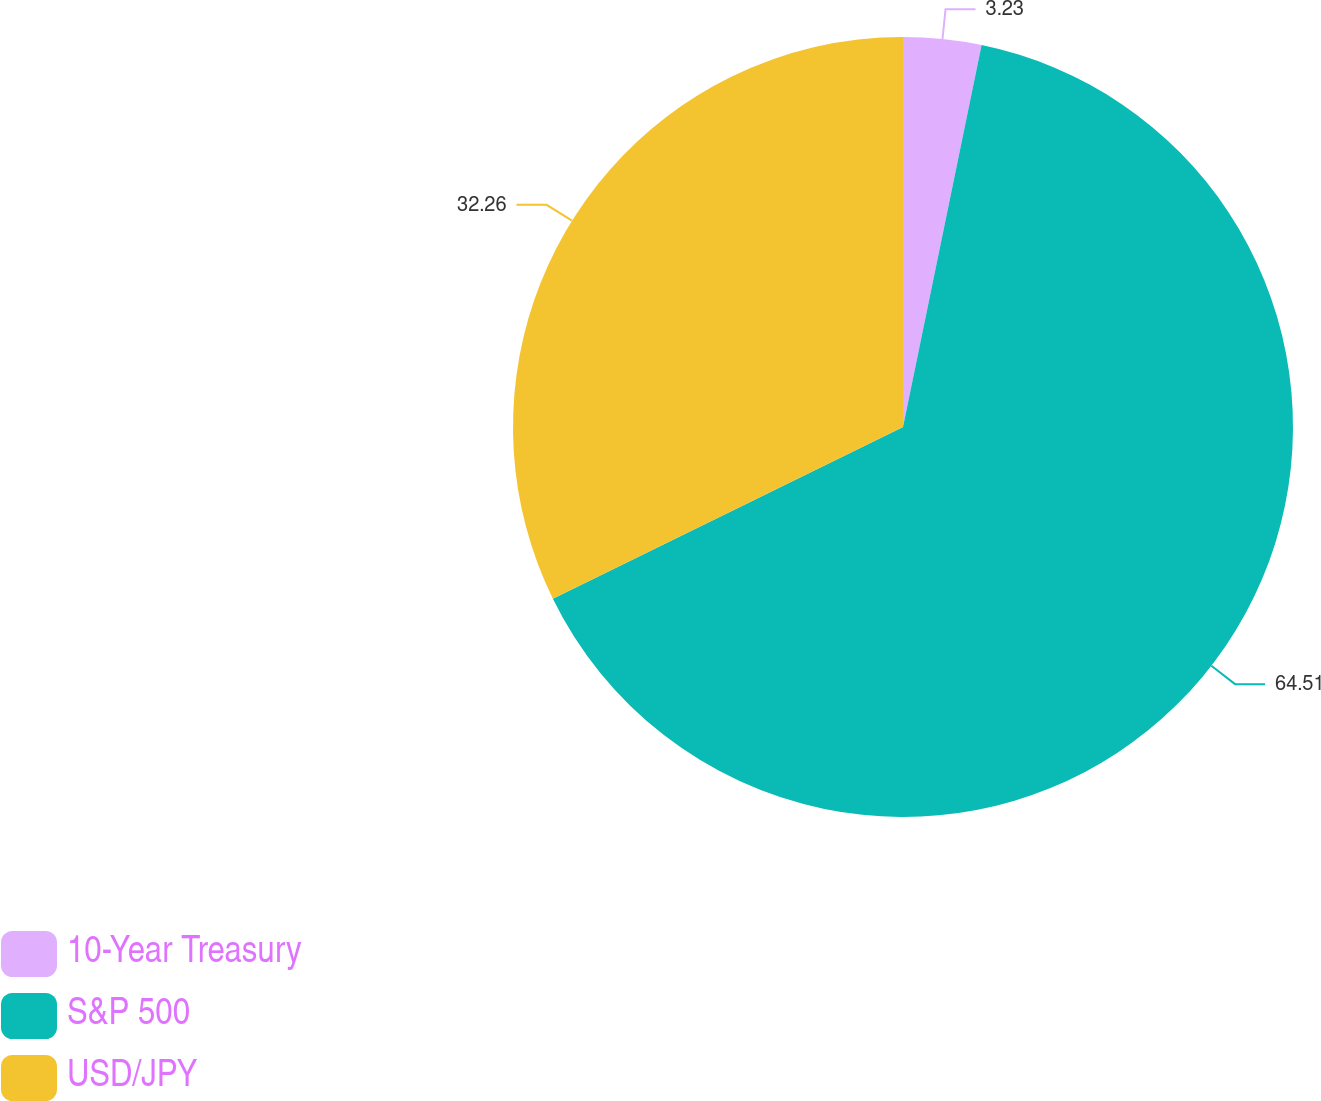Convert chart to OTSL. <chart><loc_0><loc_0><loc_500><loc_500><pie_chart><fcel>10-Year Treasury<fcel>S&P 500<fcel>USD/JPY<nl><fcel>3.23%<fcel>64.52%<fcel>32.26%<nl></chart> 